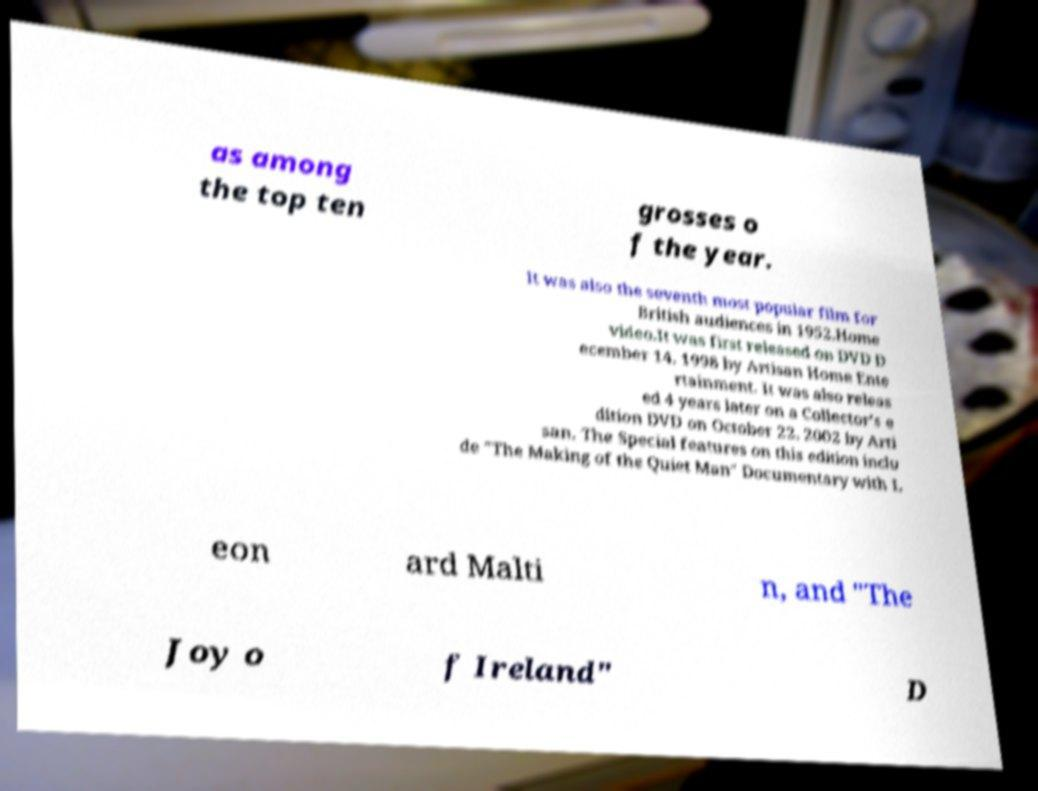Can you accurately transcribe the text from the provided image for me? as among the top ten grosses o f the year. It was also the seventh most popular film for British audiences in 1952.Home video.It was first released on DVD D ecember 14, 1998 by Artisan Home Ente rtainment. It was also releas ed 4 years later on a Collector's e dition DVD on October 22, 2002 by Arti san. The Special features on this edition inclu de "The Making of the Quiet Man" Documentary with L eon ard Malti n, and "The Joy o f Ireland" D 